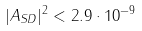<formula> <loc_0><loc_0><loc_500><loc_500>| A _ { S D } | ^ { 2 } < 2 . 9 \cdot 1 0 ^ { - 9 }</formula> 